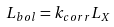Convert formula to latex. <formula><loc_0><loc_0><loc_500><loc_500>L _ { b o l } = k _ { c o r r } L _ { X }</formula> 